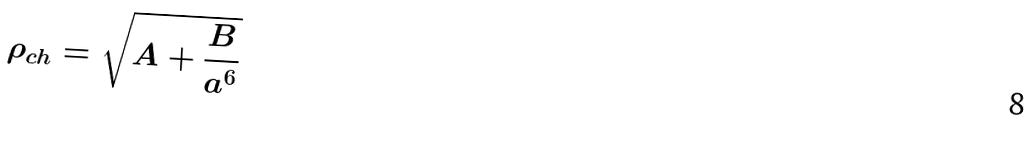Convert formula to latex. <formula><loc_0><loc_0><loc_500><loc_500>\rho _ { c h } = \sqrt { A + \frac { B } { a ^ { 6 } } }</formula> 